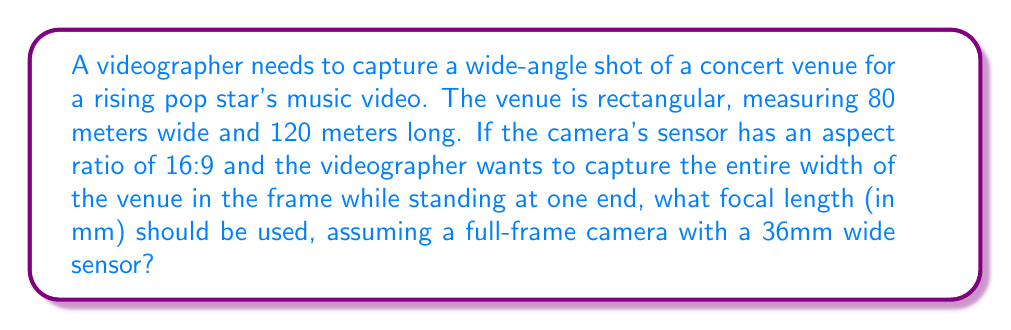Teach me how to tackle this problem. To solve this problem, we'll follow these steps:

1) First, we need to determine the angle of view required to capture the entire width of the venue.

2) The angle of view can be calculated using the formula:
   $$\theta = 2 \arctan(\frac{w}{2d})$$
   where $\theta$ is the angle of view, $w$ is the width of the scene, and $d$ is the distance from the camera to the scene.

3) In this case, $w = 80$ meters (width of the venue), and $d = 120$ meters (length of the venue, as the videographer is at one end).

4) Plugging these values into the formula:
   $$\theta = 2 \arctan(\frac{80}{2 \cdot 120}) = 2 \arctan(\frac{1}{3}) \approx 36.87°$$

5) Now that we have the angle of view, we can calculate the focal length using the formula:
   $$f = \frac{w_s}{2 \tan(\frac{\theta}{2})}$$
   where $f$ is the focal length, $w_s$ is the width of the sensor, and $\theta$ is the angle of view.

6) We know the sensor is 36mm wide (full-frame), so $w_s = 36$mm.

7) Plugging in the values:
   $$f = \frac{36}{2 \tan(\frac{36.87°}{2})} \approx 54.43\text{ mm}$$

8) Rounding to the nearest standard focal length, we get 55mm.
Answer: 55mm 